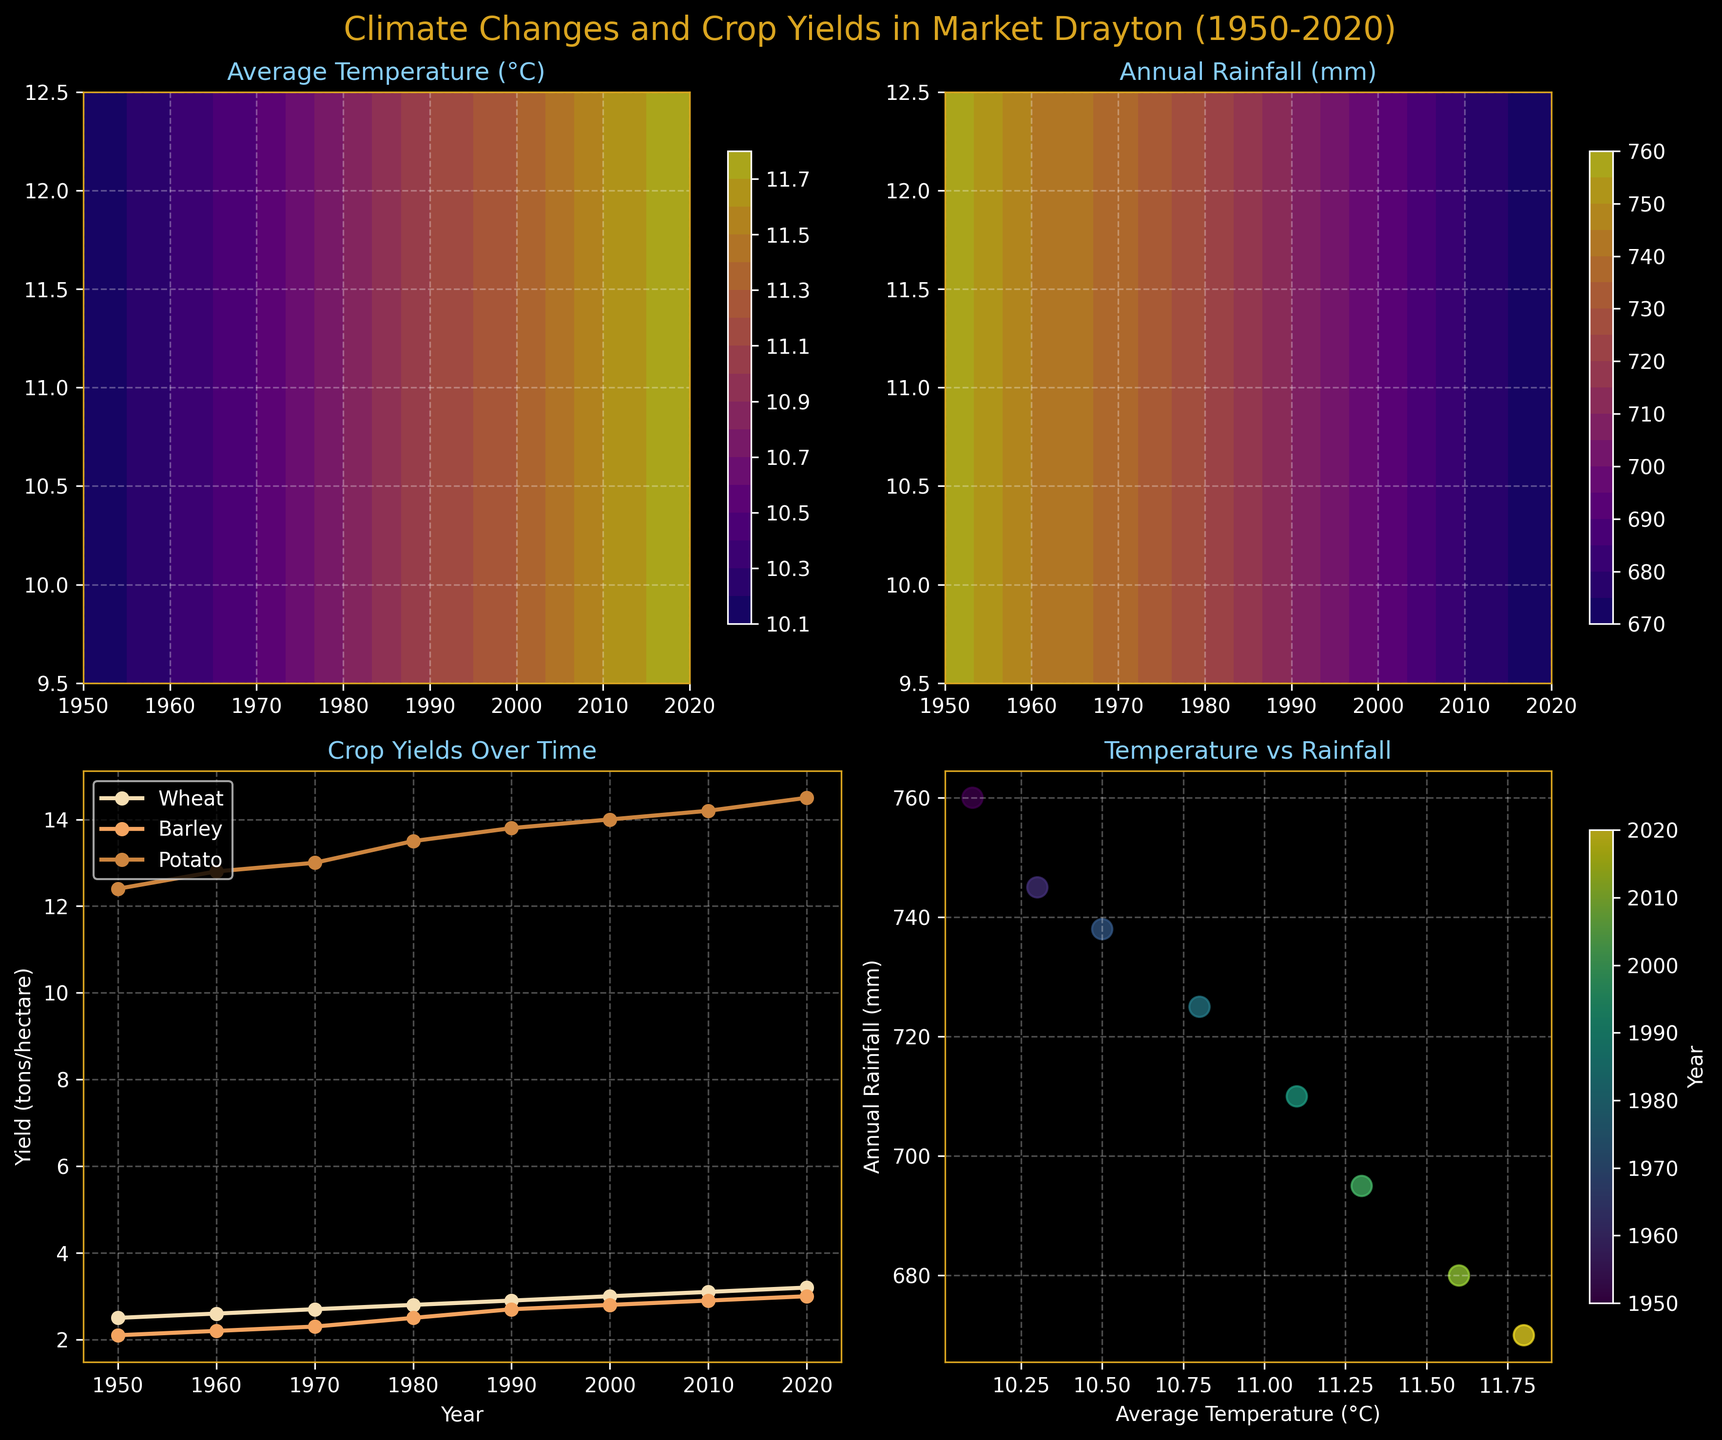What is the range of years displayed in all plots? The x-axis of the first three subplots and the color bar of the fourth subplot show the range of years. It starts at 1950 and ends at 2020.
Answer: 1950 to 2020 What color is used to represent Average Temperature in its contour plot? The contour plot of Average Temperature (top left subplot) uses a color map with shades varying from light to dark tones of purple and yellow.
Answer: Purple and Yellow How have the average temperatures changed from 1950 to 2020? The top left contour plot shows an increasing trend in average temperatures over the years, moving upwards in the color scale.
Answer: Increased What are the approximate average temperature and rainfall in the year 2000? Referencing both contour plots, in 2000, the average temperature is around 11.3°C and the annual rainfall is around 695 mm.
Answer: 11.3°C, 695 mm Which crop yield has increased most consistently over the years? The bottom left subplot shows the yields of different crops. By comparing the lines, Wheat Yield shows a consistent upward trend.
Answer: Wheat Is there any visible relationship between average temperature and potato yield over time? By observing the bottom left plot, we see that as the average temperature increases (top left plot), the potato yield also trends upward.
Answer: Positive relationship Which year had the lowest annual rainfall? By looking at the bottom right subplot and observing the color bar as well as the data points on the second contour plot, the year 2020 had the lowest rainfall at 670 mm.
Answer: 2020 How does the annual rainfall trend from 1950 to 2020? The top right contour plot shows a decreasing trend in annual rainfall over the years, moving downwards in the color scale.
Answer: Decreased Are there more years with average temperatures above or below 11°C in the timeline? By observing the contour plot of Average Temperature, we see that after the midpoint (1980s), the colors representing temperatures above 11°C appear more frequently.
Answer: Above Which decade shows the most significant increase in barley yield? Examining the bottom left plot, the sharpest increase in Barley Yield is seen between 1970 and 1980.
Answer: 1970-1980 